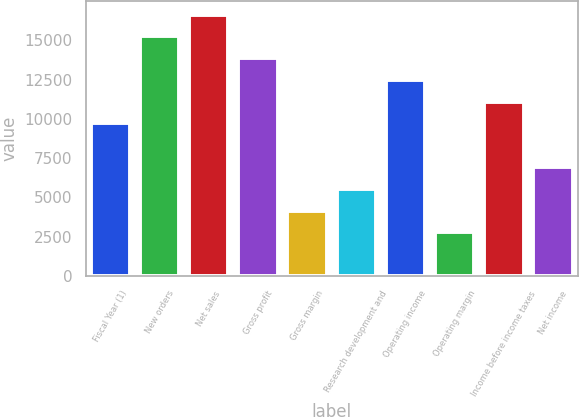<chart> <loc_0><loc_0><loc_500><loc_500><bar_chart><fcel>Fiscal Year (1)<fcel>New orders<fcel>Net sales<fcel>Gross profit<fcel>Gross margin<fcel>Research development and<fcel>Operating income<fcel>Operating margin<fcel>Income before income taxes<fcel>Net income<nl><fcel>9702.8<fcel>15247.1<fcel>16633.2<fcel>13861<fcel>4158.52<fcel>5544.59<fcel>12474.9<fcel>2772.45<fcel>11088.9<fcel>6930.66<nl></chart> 